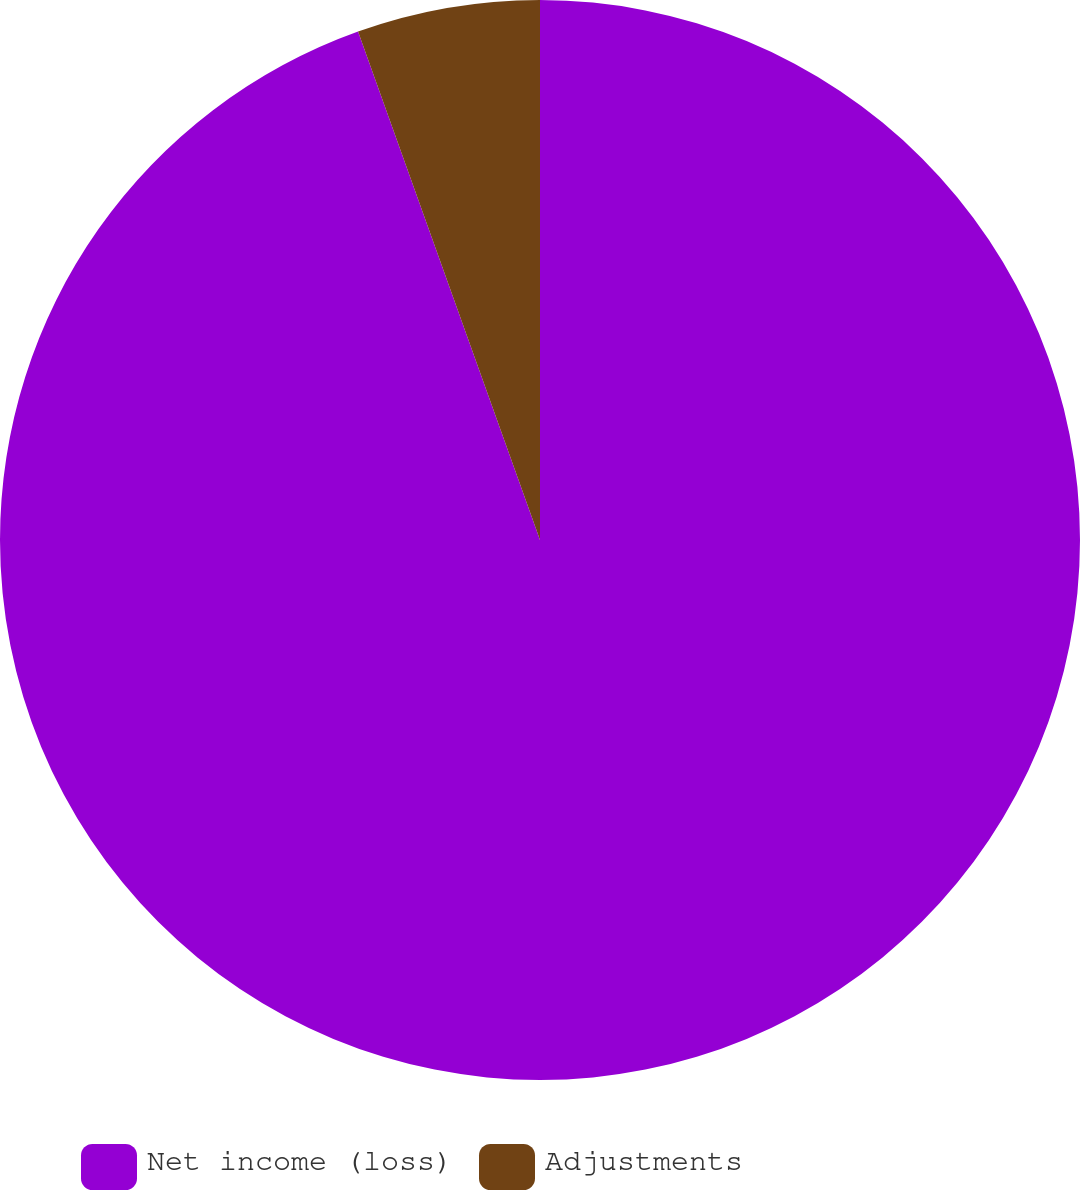Convert chart to OTSL. <chart><loc_0><loc_0><loc_500><loc_500><pie_chart><fcel>Net income (loss)<fcel>Adjustments<nl><fcel>94.53%<fcel>5.47%<nl></chart> 